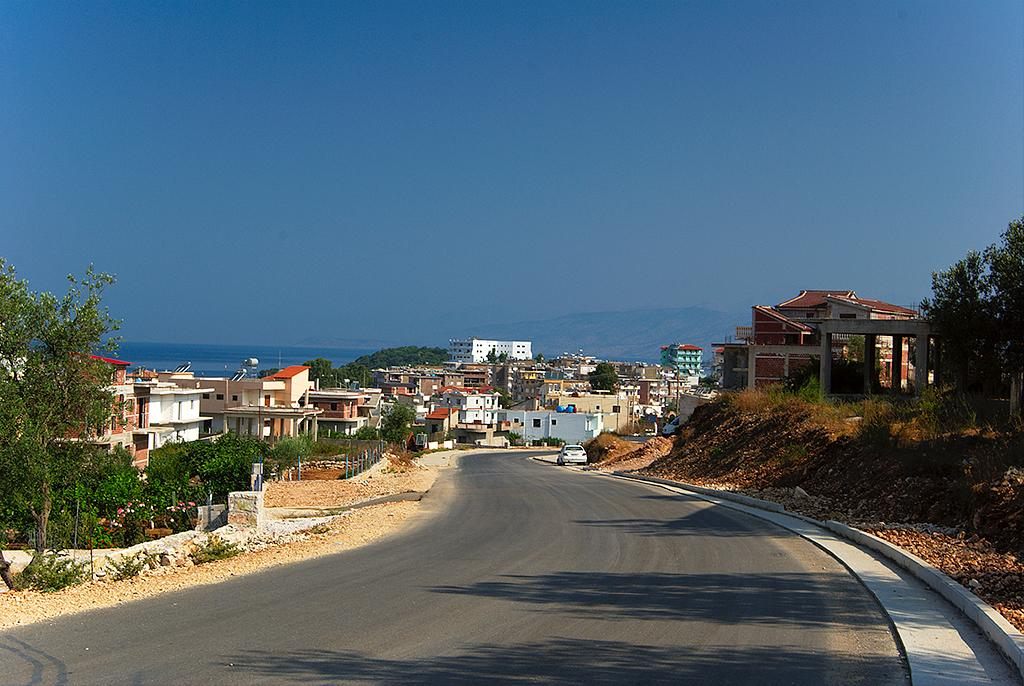What is the main feature of the image? There is a road in the image. What type of vehicle can be seen on the road? There is a car in the image. What natural elements are present in the image? Leaves, grass, plants, and trees are visible in the image. What can be seen in the background of the image? Buildings, water, a hill, and a blue sky are visible in the background of the image. What type of berry is being used as a haircut accessory in the image? There is no berry or haircut present in the image. 